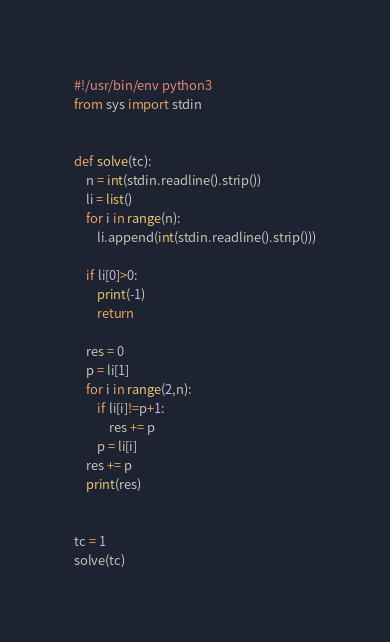Convert code to text. <code><loc_0><loc_0><loc_500><loc_500><_Python_>#!/usr/bin/env python3
from sys import stdin


def solve(tc):
    n = int(stdin.readline().strip())
    li = list()
    for i in range(n):
        li.append(int(stdin.readline().strip()))

    if li[0]>0:
        print(-1)
        return

    res = 0
    p = li[1]
    for i in range(2,n):
        if li[i]!=p+1:
            res += p
        p = li[i]
    res += p
    print(res)


tc = 1
solve(tc)</code> 